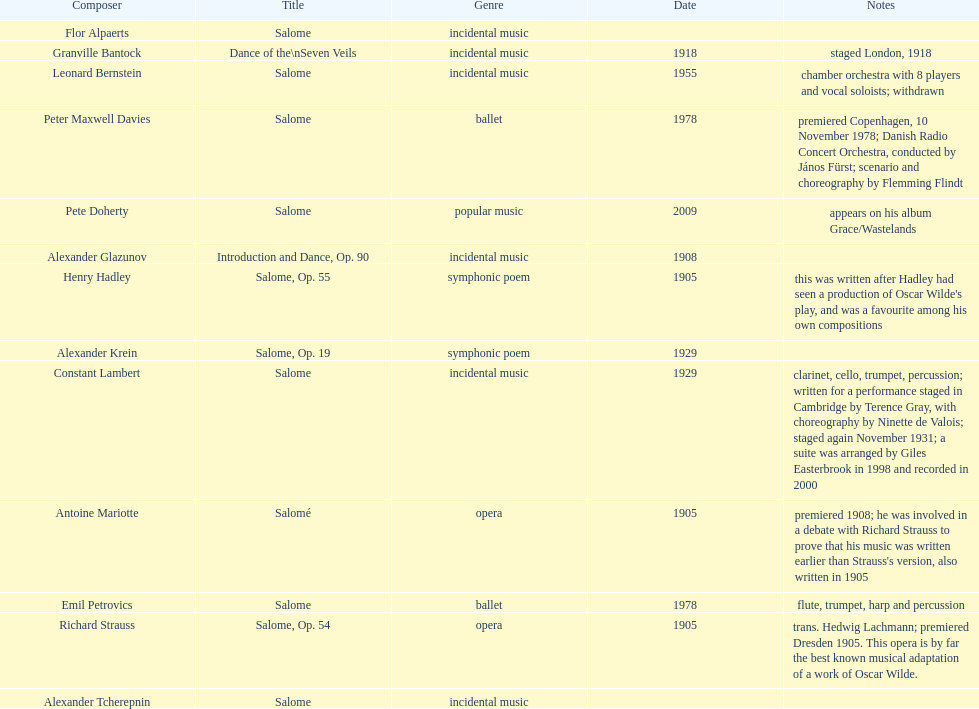After alexander krein, who is the next person on the list? Constant Lambert. 